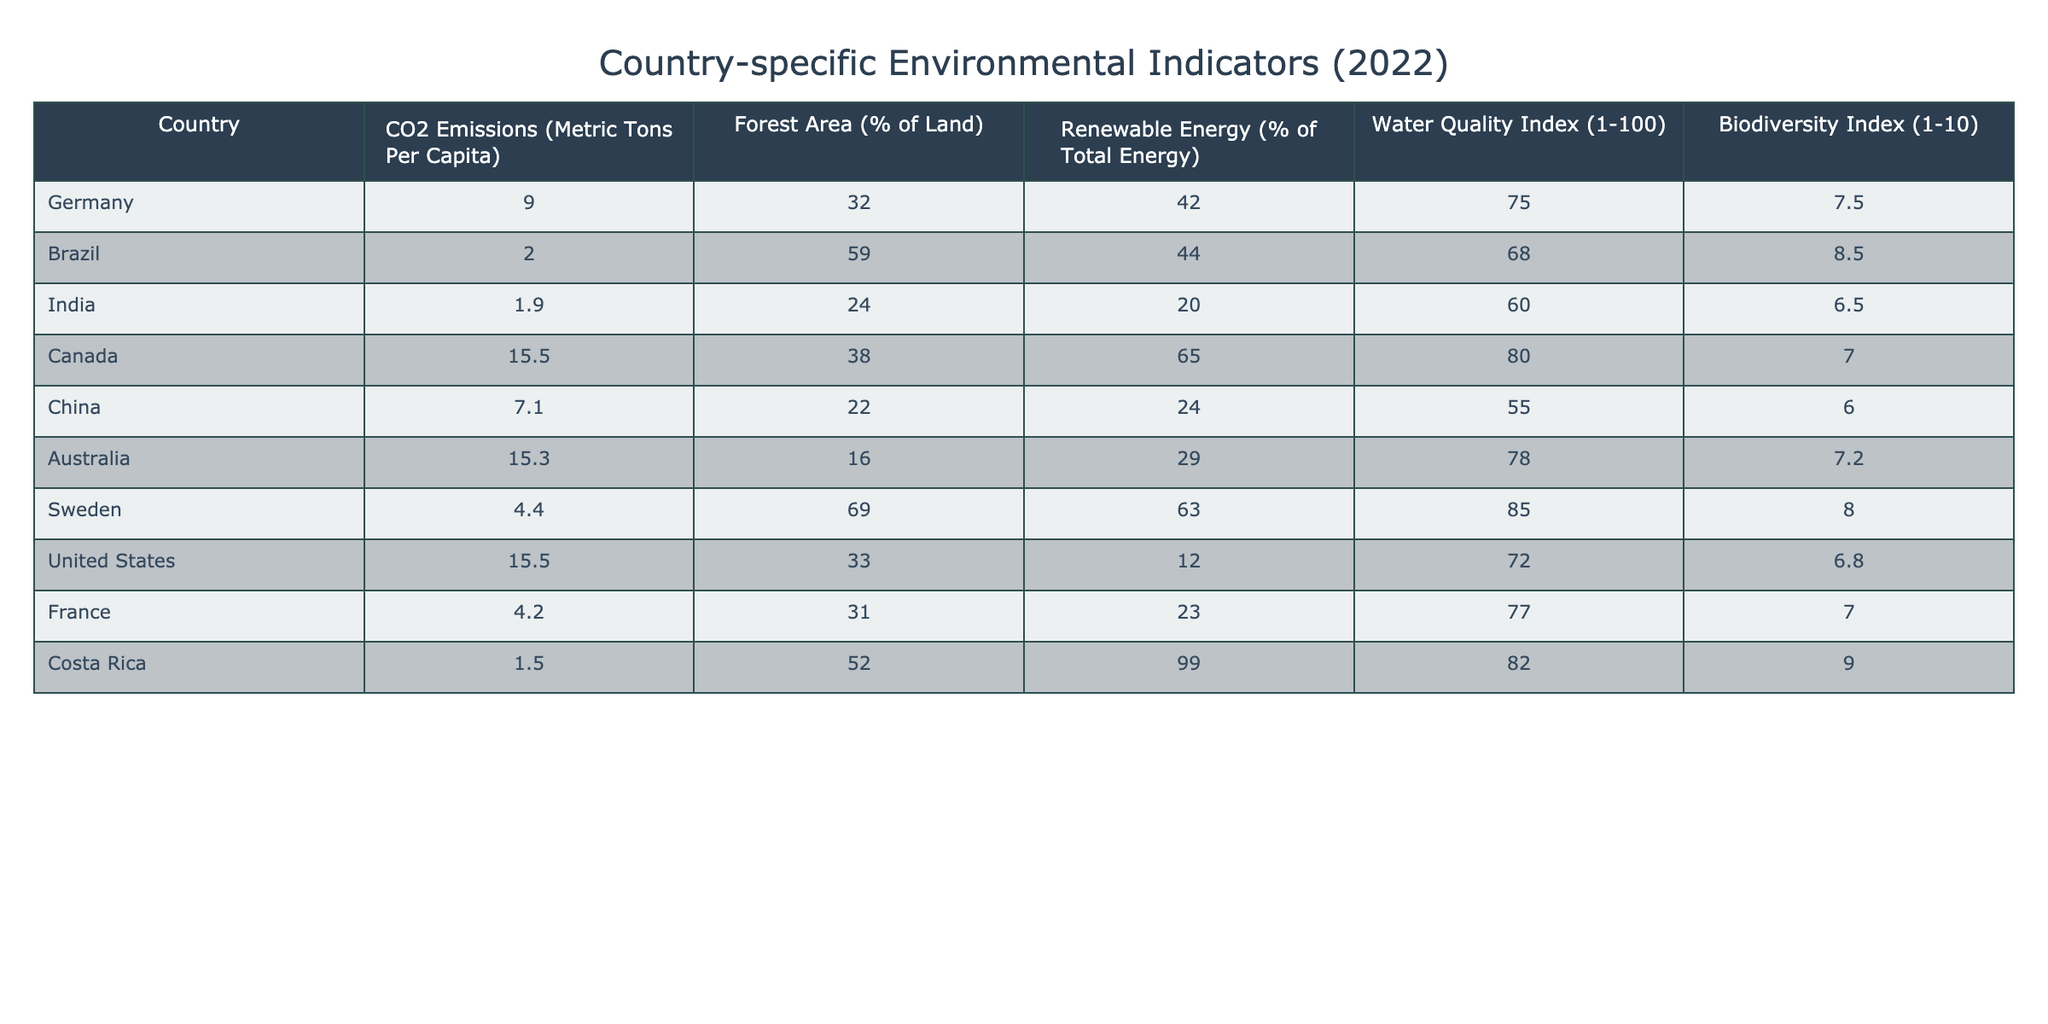What is the CO2 emissions per capita for Brazil? In the table, I locate Brazil's row and check the corresponding column for CO2 emissions per capita. Brazil has a value of 2.0 metric tons per capita.
Answer: 2.0 Which country has the highest Forest Area percentage? Scanning through the Forest Area percentage column, I find that Sweden has the highest value at 69.0%.
Answer: 69.0% Is the Biodiversity Index for Canada greater than 7? Looking at the Biodiversity Index for Canada in the table, I see it is 7.0. Since 7 is not greater than 7, the answer is no.
Answer: No What is the average Renewable Energy percentage among the listed countries? I calculate the average by summing the Renewable Energy percentages: (42.0 + 44.0 + 20.0 + 65.0 + 24.0 + 29.0 + 63.0 + 12.0 + 23.0 + 99.0) =  422.0. There are 10 countries, so the average is 422.0 / 10 = 42.2.
Answer: 42.2 Which country has a Water Quality Index above 80? I evaluate each country’s Water Quality Index and find that Canada (80) and Costa Rica (82) both exceed 80.
Answer: Canada, Costa Rica What is the difference in CO2 emissions per capita between the United States and Germany? The CO2 emissions for the United States is 15.5 and for Germany it is 9.0. The difference is calculated as 15.5 - 9.0 = 6.5 metric tons per capita.
Answer: 6.5 How many countries have a Biodiversity Index greater than 7? I review the Biodiversity Index values and find that Brazil (8.5) and Costa Rica (9.0) have values greater than 7. This totals to 2 countries.
Answer: 2 Is it true that Australia has a higher Renewable Energy percentage than China? Upon comparing the values, Australia's Renewable Energy percentage is 29.0 while China's is 24.0. Since 29.0 is greater than 24.0, the statement is true.
Answer: Yes What is the sum of CO2 emissions per capita for all countries in the table? I add all the values for CO2 emissions per capita: (9.0 + 2.0 + 1.9 + 15.5 + 7.1 + 15.3 + 4.4 + 15.5 + 4.2 + 1.5) = 62.0 metric tons.
Answer: 62.0 